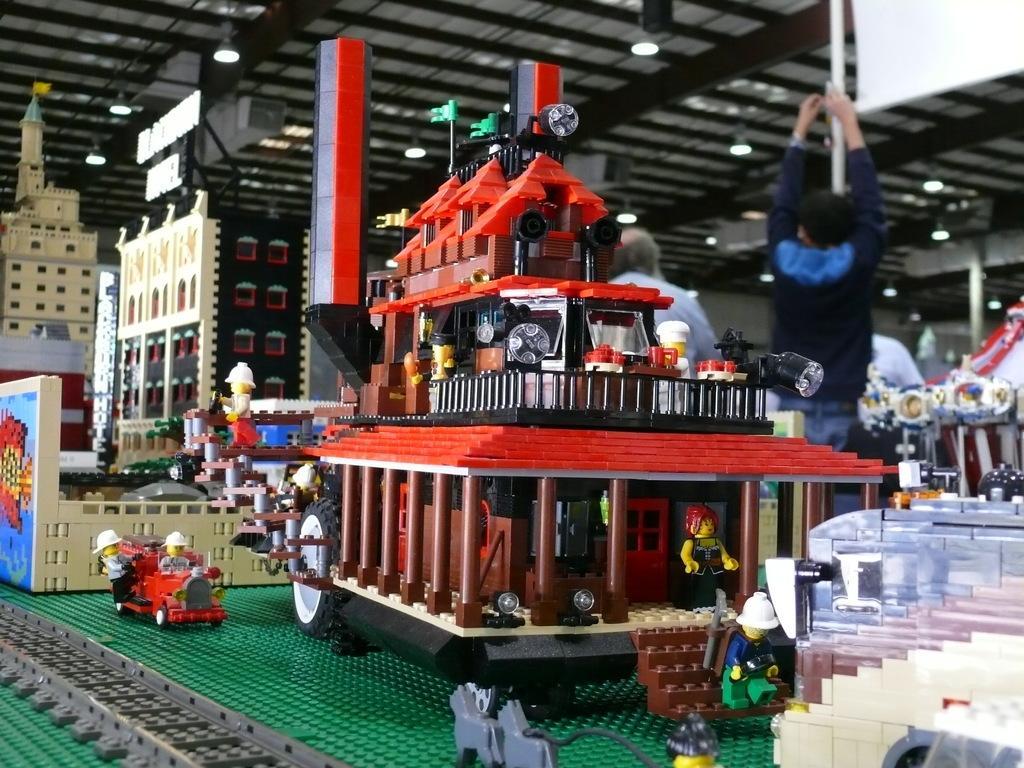Describe this image in one or two sentences. In front of the image there are toys with building blocks. Behind them there are two persons. At the top of the image there is a ceiling with lights. 